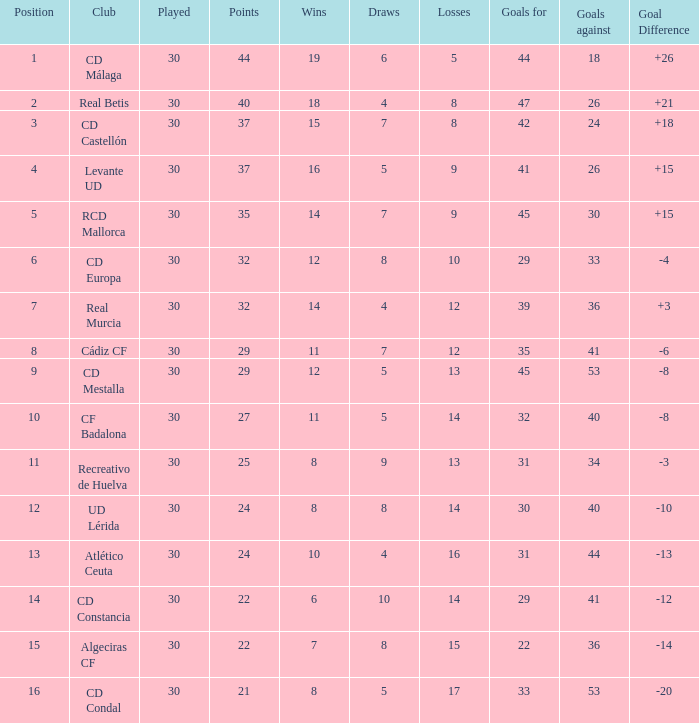What is the wins number when the points were smaller than 27, and goals against was 41? 6.0. 